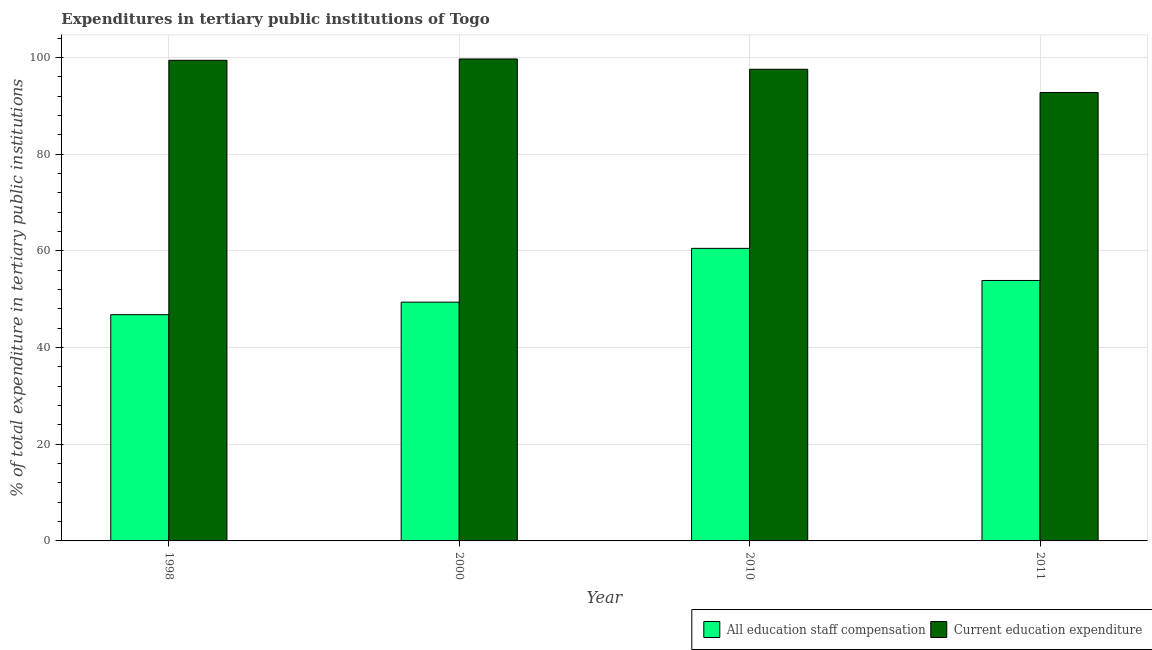How many groups of bars are there?
Provide a short and direct response. 4. Are the number of bars per tick equal to the number of legend labels?
Provide a succinct answer. Yes. Are the number of bars on each tick of the X-axis equal?
Keep it short and to the point. Yes. How many bars are there on the 4th tick from the left?
Your response must be concise. 2. What is the label of the 4th group of bars from the left?
Your answer should be compact. 2011. In how many cases, is the number of bars for a given year not equal to the number of legend labels?
Ensure brevity in your answer.  0. What is the expenditure in staff compensation in 2000?
Provide a succinct answer. 49.4. Across all years, what is the maximum expenditure in education?
Provide a succinct answer. 99.72. Across all years, what is the minimum expenditure in education?
Your response must be concise. 92.78. What is the total expenditure in education in the graph?
Your answer should be compact. 389.54. What is the difference between the expenditure in education in 2000 and that in 2010?
Ensure brevity in your answer.  2.13. What is the difference between the expenditure in staff compensation in 2011 and the expenditure in education in 1998?
Give a very brief answer. 7.08. What is the average expenditure in staff compensation per year?
Ensure brevity in your answer.  52.66. In the year 1998, what is the difference between the expenditure in education and expenditure in staff compensation?
Give a very brief answer. 0. In how many years, is the expenditure in staff compensation greater than 76 %?
Provide a short and direct response. 0. What is the ratio of the expenditure in education in 2000 to that in 2010?
Your answer should be compact. 1.02. Is the difference between the expenditure in staff compensation in 1998 and 2011 greater than the difference between the expenditure in education in 1998 and 2011?
Give a very brief answer. No. What is the difference between the highest and the second highest expenditure in staff compensation?
Give a very brief answer. 6.64. What is the difference between the highest and the lowest expenditure in staff compensation?
Keep it short and to the point. 13.72. In how many years, is the expenditure in education greater than the average expenditure in education taken over all years?
Your answer should be very brief. 3. What does the 2nd bar from the left in 2011 represents?
Ensure brevity in your answer.  Current education expenditure. What does the 2nd bar from the right in 2000 represents?
Provide a short and direct response. All education staff compensation. Are all the bars in the graph horizontal?
Ensure brevity in your answer.  No. Are the values on the major ticks of Y-axis written in scientific E-notation?
Ensure brevity in your answer.  No. Does the graph contain any zero values?
Your answer should be compact. No. How are the legend labels stacked?
Offer a terse response. Horizontal. What is the title of the graph?
Offer a very short reply. Expenditures in tertiary public institutions of Togo. What is the label or title of the X-axis?
Your response must be concise. Year. What is the label or title of the Y-axis?
Offer a very short reply. % of total expenditure in tertiary public institutions. What is the % of total expenditure in tertiary public institutions of All education staff compensation in 1998?
Ensure brevity in your answer.  46.81. What is the % of total expenditure in tertiary public institutions in Current education expenditure in 1998?
Provide a short and direct response. 99.45. What is the % of total expenditure in tertiary public institutions in All education staff compensation in 2000?
Ensure brevity in your answer.  49.4. What is the % of total expenditure in tertiary public institutions in Current education expenditure in 2000?
Give a very brief answer. 99.72. What is the % of total expenditure in tertiary public institutions in All education staff compensation in 2010?
Ensure brevity in your answer.  60.53. What is the % of total expenditure in tertiary public institutions of Current education expenditure in 2010?
Ensure brevity in your answer.  97.59. What is the % of total expenditure in tertiary public institutions in All education staff compensation in 2011?
Provide a succinct answer. 53.89. What is the % of total expenditure in tertiary public institutions of Current education expenditure in 2011?
Offer a terse response. 92.78. Across all years, what is the maximum % of total expenditure in tertiary public institutions in All education staff compensation?
Keep it short and to the point. 60.53. Across all years, what is the maximum % of total expenditure in tertiary public institutions of Current education expenditure?
Ensure brevity in your answer.  99.72. Across all years, what is the minimum % of total expenditure in tertiary public institutions in All education staff compensation?
Offer a terse response. 46.81. Across all years, what is the minimum % of total expenditure in tertiary public institutions in Current education expenditure?
Offer a terse response. 92.78. What is the total % of total expenditure in tertiary public institutions of All education staff compensation in the graph?
Offer a very short reply. 210.64. What is the total % of total expenditure in tertiary public institutions in Current education expenditure in the graph?
Ensure brevity in your answer.  389.54. What is the difference between the % of total expenditure in tertiary public institutions of All education staff compensation in 1998 and that in 2000?
Your answer should be very brief. -2.59. What is the difference between the % of total expenditure in tertiary public institutions in Current education expenditure in 1998 and that in 2000?
Ensure brevity in your answer.  -0.28. What is the difference between the % of total expenditure in tertiary public institutions of All education staff compensation in 1998 and that in 2010?
Provide a short and direct response. -13.72. What is the difference between the % of total expenditure in tertiary public institutions of Current education expenditure in 1998 and that in 2010?
Your answer should be very brief. 1.85. What is the difference between the % of total expenditure in tertiary public institutions in All education staff compensation in 1998 and that in 2011?
Your answer should be compact. -7.08. What is the difference between the % of total expenditure in tertiary public institutions of Current education expenditure in 1998 and that in 2011?
Offer a terse response. 6.67. What is the difference between the % of total expenditure in tertiary public institutions in All education staff compensation in 2000 and that in 2010?
Make the answer very short. -11.13. What is the difference between the % of total expenditure in tertiary public institutions of Current education expenditure in 2000 and that in 2010?
Offer a very short reply. 2.13. What is the difference between the % of total expenditure in tertiary public institutions in All education staff compensation in 2000 and that in 2011?
Give a very brief answer. -4.48. What is the difference between the % of total expenditure in tertiary public institutions in Current education expenditure in 2000 and that in 2011?
Provide a succinct answer. 6.95. What is the difference between the % of total expenditure in tertiary public institutions in All education staff compensation in 2010 and that in 2011?
Offer a terse response. 6.64. What is the difference between the % of total expenditure in tertiary public institutions of Current education expenditure in 2010 and that in 2011?
Provide a succinct answer. 4.81. What is the difference between the % of total expenditure in tertiary public institutions in All education staff compensation in 1998 and the % of total expenditure in tertiary public institutions in Current education expenditure in 2000?
Your answer should be compact. -52.91. What is the difference between the % of total expenditure in tertiary public institutions in All education staff compensation in 1998 and the % of total expenditure in tertiary public institutions in Current education expenditure in 2010?
Offer a very short reply. -50.78. What is the difference between the % of total expenditure in tertiary public institutions in All education staff compensation in 1998 and the % of total expenditure in tertiary public institutions in Current education expenditure in 2011?
Your answer should be compact. -45.97. What is the difference between the % of total expenditure in tertiary public institutions in All education staff compensation in 2000 and the % of total expenditure in tertiary public institutions in Current education expenditure in 2010?
Your answer should be very brief. -48.19. What is the difference between the % of total expenditure in tertiary public institutions in All education staff compensation in 2000 and the % of total expenditure in tertiary public institutions in Current education expenditure in 2011?
Provide a short and direct response. -43.37. What is the difference between the % of total expenditure in tertiary public institutions of All education staff compensation in 2010 and the % of total expenditure in tertiary public institutions of Current education expenditure in 2011?
Ensure brevity in your answer.  -32.24. What is the average % of total expenditure in tertiary public institutions in All education staff compensation per year?
Offer a terse response. 52.66. What is the average % of total expenditure in tertiary public institutions in Current education expenditure per year?
Make the answer very short. 97.38. In the year 1998, what is the difference between the % of total expenditure in tertiary public institutions of All education staff compensation and % of total expenditure in tertiary public institutions of Current education expenditure?
Give a very brief answer. -52.63. In the year 2000, what is the difference between the % of total expenditure in tertiary public institutions in All education staff compensation and % of total expenditure in tertiary public institutions in Current education expenditure?
Provide a short and direct response. -50.32. In the year 2010, what is the difference between the % of total expenditure in tertiary public institutions of All education staff compensation and % of total expenditure in tertiary public institutions of Current education expenditure?
Offer a very short reply. -37.06. In the year 2011, what is the difference between the % of total expenditure in tertiary public institutions of All education staff compensation and % of total expenditure in tertiary public institutions of Current education expenditure?
Provide a succinct answer. -38.89. What is the ratio of the % of total expenditure in tertiary public institutions of All education staff compensation in 1998 to that in 2000?
Give a very brief answer. 0.95. What is the ratio of the % of total expenditure in tertiary public institutions of Current education expenditure in 1998 to that in 2000?
Keep it short and to the point. 1. What is the ratio of the % of total expenditure in tertiary public institutions of All education staff compensation in 1998 to that in 2010?
Ensure brevity in your answer.  0.77. What is the ratio of the % of total expenditure in tertiary public institutions of Current education expenditure in 1998 to that in 2010?
Ensure brevity in your answer.  1.02. What is the ratio of the % of total expenditure in tertiary public institutions in All education staff compensation in 1998 to that in 2011?
Offer a terse response. 0.87. What is the ratio of the % of total expenditure in tertiary public institutions of Current education expenditure in 1998 to that in 2011?
Provide a succinct answer. 1.07. What is the ratio of the % of total expenditure in tertiary public institutions of All education staff compensation in 2000 to that in 2010?
Provide a short and direct response. 0.82. What is the ratio of the % of total expenditure in tertiary public institutions in Current education expenditure in 2000 to that in 2010?
Your answer should be very brief. 1.02. What is the ratio of the % of total expenditure in tertiary public institutions in All education staff compensation in 2000 to that in 2011?
Give a very brief answer. 0.92. What is the ratio of the % of total expenditure in tertiary public institutions in Current education expenditure in 2000 to that in 2011?
Make the answer very short. 1.07. What is the ratio of the % of total expenditure in tertiary public institutions in All education staff compensation in 2010 to that in 2011?
Provide a succinct answer. 1.12. What is the ratio of the % of total expenditure in tertiary public institutions in Current education expenditure in 2010 to that in 2011?
Provide a short and direct response. 1.05. What is the difference between the highest and the second highest % of total expenditure in tertiary public institutions of All education staff compensation?
Offer a terse response. 6.64. What is the difference between the highest and the second highest % of total expenditure in tertiary public institutions of Current education expenditure?
Offer a very short reply. 0.28. What is the difference between the highest and the lowest % of total expenditure in tertiary public institutions of All education staff compensation?
Make the answer very short. 13.72. What is the difference between the highest and the lowest % of total expenditure in tertiary public institutions in Current education expenditure?
Your answer should be compact. 6.95. 